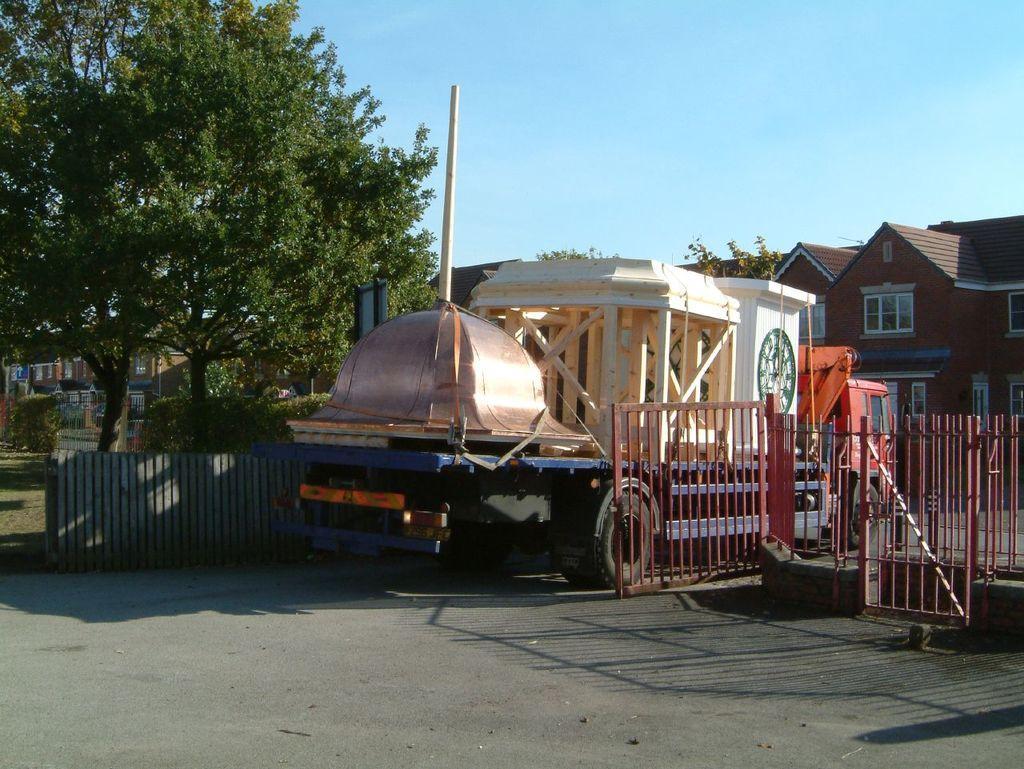Please provide a concise description of this image. In the center of the image there is a vehicle on the road. On the right side of the image we can see trees, buildings and gate. On the left side of the image buildings, fencing and trees. In the background there is sky. 